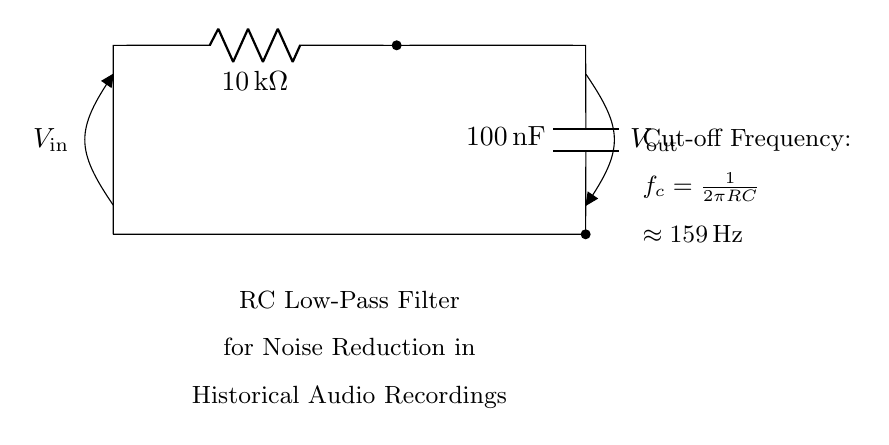What type of filter is represented by this circuit? The circuit is labeled as a "RC Low-Pass Filter." This indicates that it allows low-frequency signals to pass through while attenuating higher-frequency signals. The components and layout confirm it is designed to achieve this filtering effect.
Answer: Low-Pass Filter What is the resistance value of the resistor in this circuit? The circuit diagram indicates that the resistor is labeled with a value of "10 kΩ." This is a basic descriptive question that can be directly answered by reading the value written in the diagram.
Answer: 10 kΩ What is the capacitance value of the capacitor in this circuit? The value of the capacitor is clearly marked as "100 nF" in the diagram. The question requires identifying the capacitance value associated with the capacitor component depicted in the circuit.
Answer: 100 nF What is the cut-off frequency of this filter circuit? The cut-off frequency is calculated using the formula f_c = 1/(2πRC). The diagram provides both values: R as 10 kΩ and C as 100 nF. Performing the calculation gives f_c ≈ 159 Hz, which is also stated in the diagram.
Answer: 159 Hz Why is the RC filter used for noise reduction in historical audio recordings? The RC filter allows low-frequency audio signals to pass while filtering out higher-frequency noise; this is particularly useful for historical audio recordings, which often contain unwanted high-frequency artifacts. By retaining the desired audio frequencies and reducing noise, the quality of the recordings improves significantly.
Answer: To reduce noise How are the components in this RC circuit connected? The components are connected in series: the input voltage source is connected to the resistor, which is connected to the capacitor, and finally, the capacitor is connected back to ground. The output voltage is taken across the capacitor, making this a typical configuration for an RC filter.
Answer: In series What happens to the output voltage as the frequency increases? As the frequency increases, the output voltage across the capacitor decreases. This behavior is characteristic of a low-pass filter: at higher frequencies, the impedance of the capacitor becomes lower, causing more of the signal to be shunted to ground rather than appearing at the output.
Answer: Decreases 